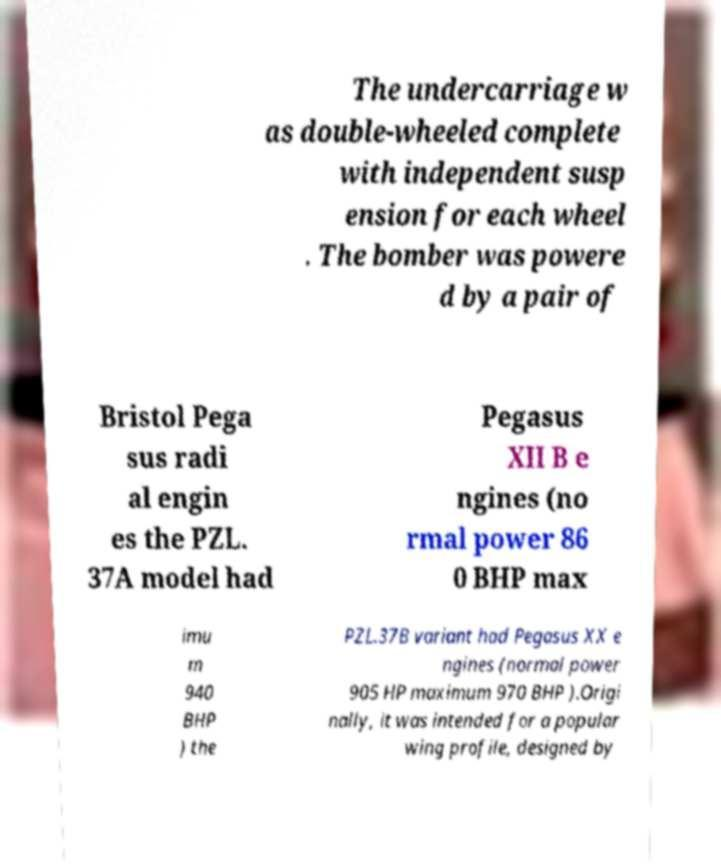What messages or text are displayed in this image? I need them in a readable, typed format. The undercarriage w as double-wheeled complete with independent susp ension for each wheel . The bomber was powere d by a pair of Bristol Pega sus radi al engin es the PZL. 37A model had Pegasus XII B e ngines (no rmal power 86 0 BHP max imu m 940 BHP ) the PZL.37B variant had Pegasus XX e ngines (normal power 905 HP maximum 970 BHP ).Origi nally, it was intended for a popular wing profile, designed by 